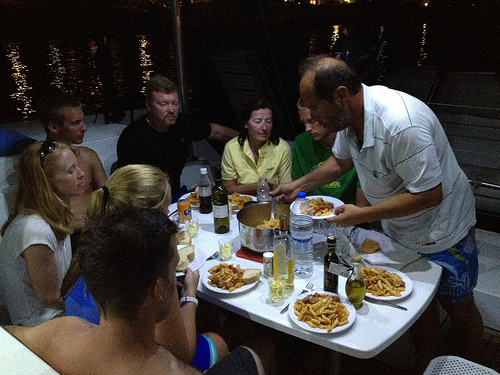Please provide the bounding box coordinate of the region this sentence describes: large plastic water bottle. The identified region of [0.56, 0.5, 0.63, 0.7] precisely encapsulates the placement of a sizable plastic water bottle on the table among a social gathering. 